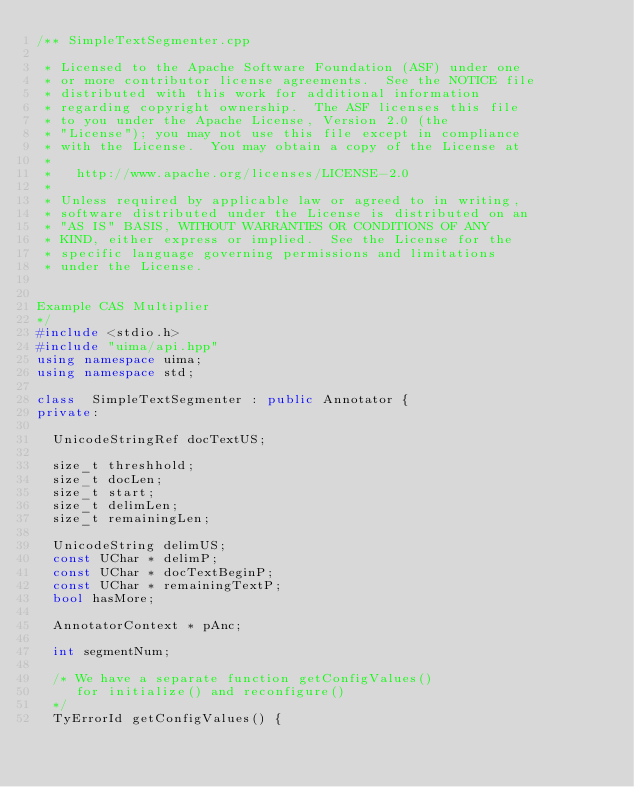<code> <loc_0><loc_0><loc_500><loc_500><_C++_>/** SimpleTextSegmenter.cpp

 * Licensed to the Apache Software Foundation (ASF) under one
 * or more contributor license agreements.  See the NOTICE file
 * distributed with this work for additional information
 * regarding copyright ownership.  The ASF licenses this file
 * to you under the Apache License, Version 2.0 (the
 * "License"); you may not use this file except in compliance
 * with the License.  You may obtain a copy of the License at
 *
 *   http://www.apache.org/licenses/LICENSE-2.0
 *
 * Unless required by applicable law or agreed to in writing,
 * software distributed under the License is distributed on an
 * "AS IS" BASIS, WITHOUT WARRANTIES OR CONDITIONS OF ANY
 * KIND, either express or implied.  See the License for the
 * specific language governing permissions and limitations
 * under the License.


Example CAS Multiplier
*/
#include <stdio.h>
#include "uima/api.hpp"
using namespace uima;
using namespace std;

class  SimpleTextSegmenter : public Annotator {
private:

  UnicodeStringRef docTextUS;

  size_t threshhold;
  size_t docLen;
  size_t start;
  size_t delimLen;
  size_t remainingLen;

  UnicodeString delimUS;
  const UChar * delimP;
  const UChar * docTextBeginP;
  const UChar * remainingTextP;
  bool hasMore;

  AnnotatorContext * pAnc;

  int segmentNum;

  /* We have a separate function getConfigValues()
     for initialize() and reconfigure()
  */
  TyErrorId getConfigValues() {</code> 